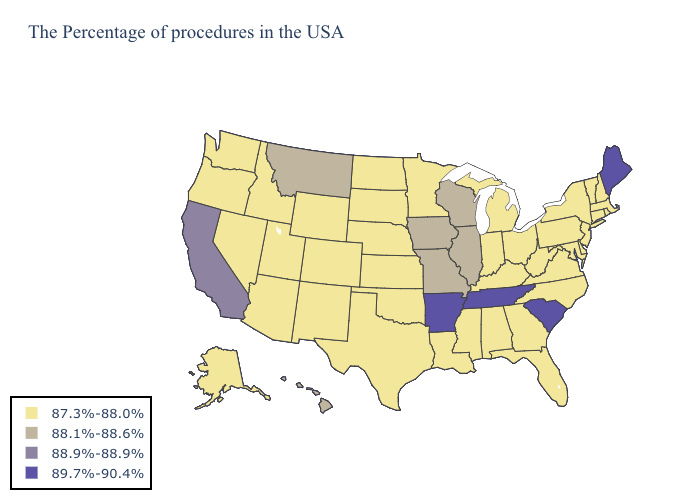What is the lowest value in the West?
Keep it brief. 87.3%-88.0%. What is the value of Michigan?
Concise answer only. 87.3%-88.0%. What is the value of South Dakota?
Answer briefly. 87.3%-88.0%. What is the highest value in states that border Massachusetts?
Concise answer only. 87.3%-88.0%. What is the lowest value in the Northeast?
Concise answer only. 87.3%-88.0%. What is the highest value in the Northeast ?
Keep it brief. 89.7%-90.4%. Does the first symbol in the legend represent the smallest category?
Concise answer only. Yes. Does Georgia have the lowest value in the USA?
Concise answer only. Yes. Among the states that border Illinois , does Kentucky have the highest value?
Short answer required. No. Name the states that have a value in the range 89.7%-90.4%?
Short answer required. Maine, South Carolina, Tennessee, Arkansas. Name the states that have a value in the range 87.3%-88.0%?
Answer briefly. Massachusetts, Rhode Island, New Hampshire, Vermont, Connecticut, New York, New Jersey, Delaware, Maryland, Pennsylvania, Virginia, North Carolina, West Virginia, Ohio, Florida, Georgia, Michigan, Kentucky, Indiana, Alabama, Mississippi, Louisiana, Minnesota, Kansas, Nebraska, Oklahoma, Texas, South Dakota, North Dakota, Wyoming, Colorado, New Mexico, Utah, Arizona, Idaho, Nevada, Washington, Oregon, Alaska. What is the highest value in states that border Wyoming?
Give a very brief answer. 88.1%-88.6%. Which states have the highest value in the USA?
Quick response, please. Maine, South Carolina, Tennessee, Arkansas. Does South Carolina have the lowest value in the South?
Write a very short answer. No. 